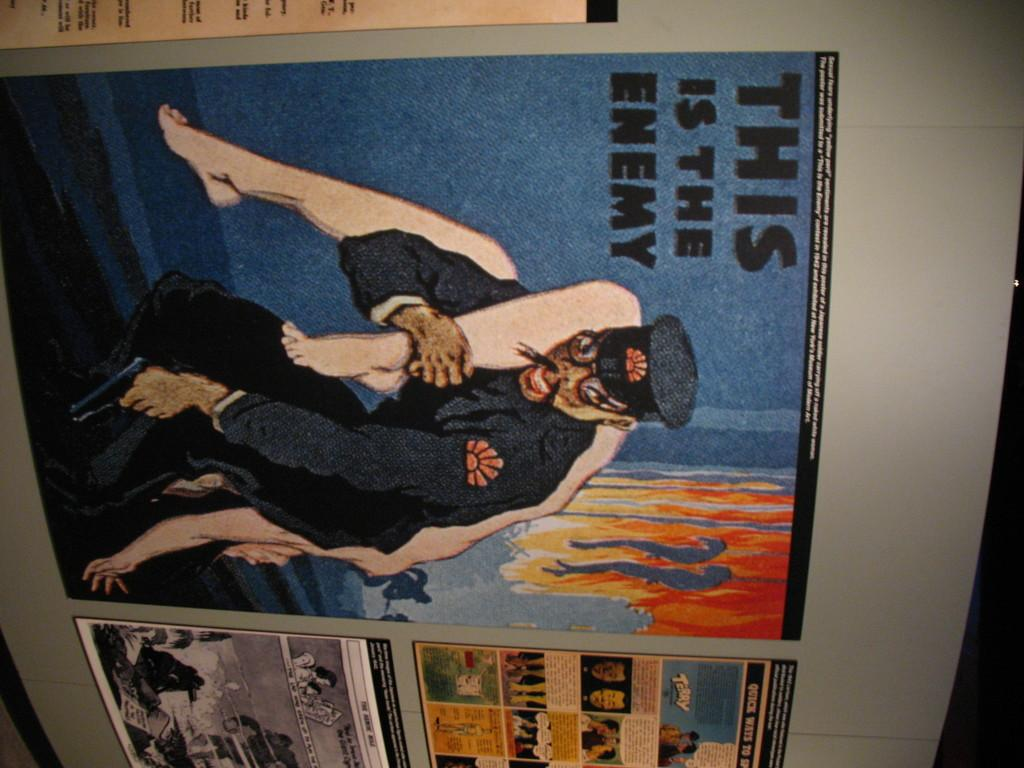<image>
Render a clear and concise summary of the photo. A large picture of someone carrying someone else warns that this is the enemy. 